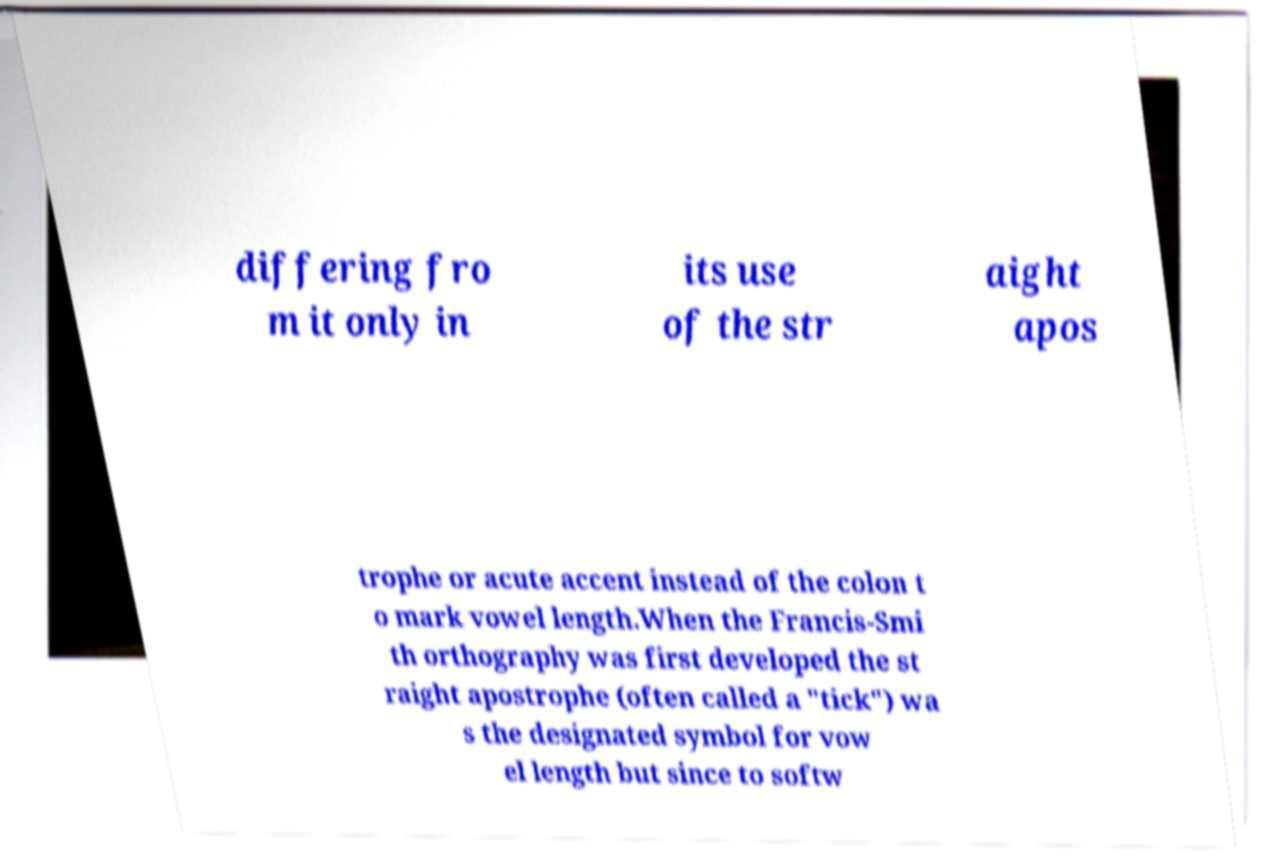Can you read and provide the text displayed in the image?This photo seems to have some interesting text. Can you extract and type it out for me? differing fro m it only in its use of the str aight apos trophe or acute accent instead of the colon t o mark vowel length.When the Francis-Smi th orthography was first developed the st raight apostrophe (often called a "tick") wa s the designated symbol for vow el length but since to softw 